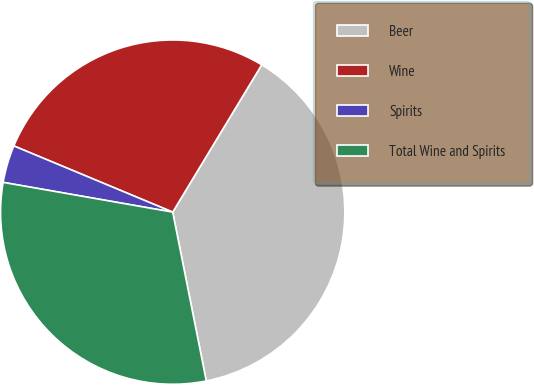<chart> <loc_0><loc_0><loc_500><loc_500><pie_chart><fcel>Beer<fcel>Wine<fcel>Spirits<fcel>Total Wine and Spirits<nl><fcel>38.22%<fcel>27.37%<fcel>3.52%<fcel>30.89%<nl></chart> 